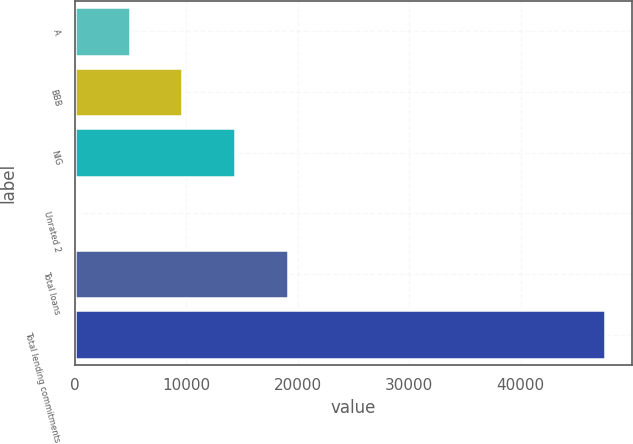Convert chart. <chart><loc_0><loc_0><loc_500><loc_500><bar_chart><fcel>A<fcel>BBB<fcel>NIG<fcel>Unrated 2<fcel>Total loans<fcel>Total lending commitments<nl><fcel>4916.4<fcel>9657.8<fcel>14399.2<fcel>175<fcel>19140.6<fcel>47589<nl></chart> 